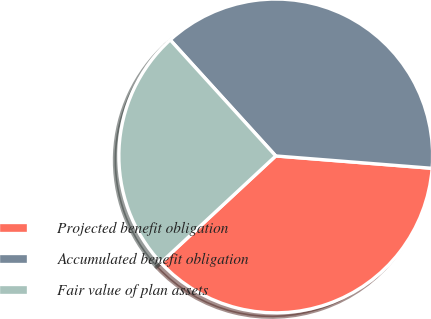<chart> <loc_0><loc_0><loc_500><loc_500><pie_chart><fcel>Projected benefit obligation<fcel>Accumulated benefit obligation<fcel>Fair value of plan assets<nl><fcel>36.83%<fcel>38.0%<fcel>25.17%<nl></chart> 